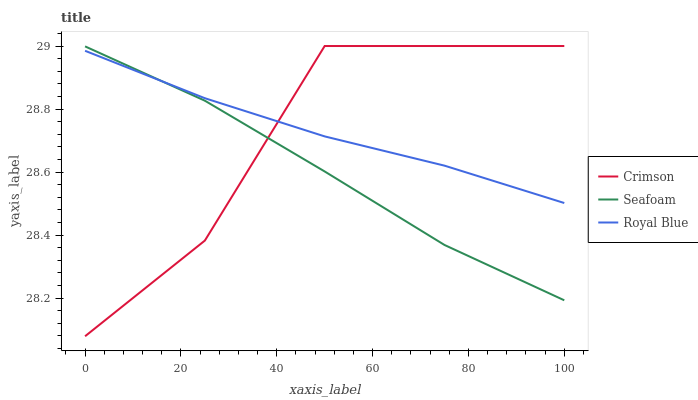Does Seafoam have the minimum area under the curve?
Answer yes or no. Yes. Does Crimson have the maximum area under the curve?
Answer yes or no. Yes. Does Royal Blue have the minimum area under the curve?
Answer yes or no. No. Does Royal Blue have the maximum area under the curve?
Answer yes or no. No. Is Royal Blue the smoothest?
Answer yes or no. Yes. Is Crimson the roughest?
Answer yes or no. Yes. Is Seafoam the smoothest?
Answer yes or no. No. Is Seafoam the roughest?
Answer yes or no. No. Does Crimson have the lowest value?
Answer yes or no. Yes. Does Seafoam have the lowest value?
Answer yes or no. No. Does Crimson have the highest value?
Answer yes or no. Yes. Does Seafoam have the highest value?
Answer yes or no. No. Does Seafoam intersect Crimson?
Answer yes or no. Yes. Is Seafoam less than Crimson?
Answer yes or no. No. Is Seafoam greater than Crimson?
Answer yes or no. No. 